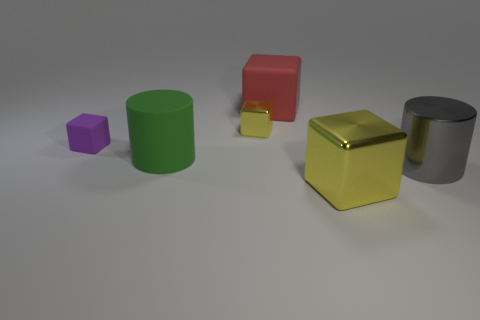Add 2 tiny yellow metallic cubes. How many objects exist? 8 Subtract all cubes. How many objects are left? 2 Add 6 matte blocks. How many matte blocks are left? 8 Add 1 large purple cylinders. How many large purple cylinders exist? 1 Subtract 0 green spheres. How many objects are left? 6 Subtract all big cylinders. Subtract all shiny objects. How many objects are left? 1 